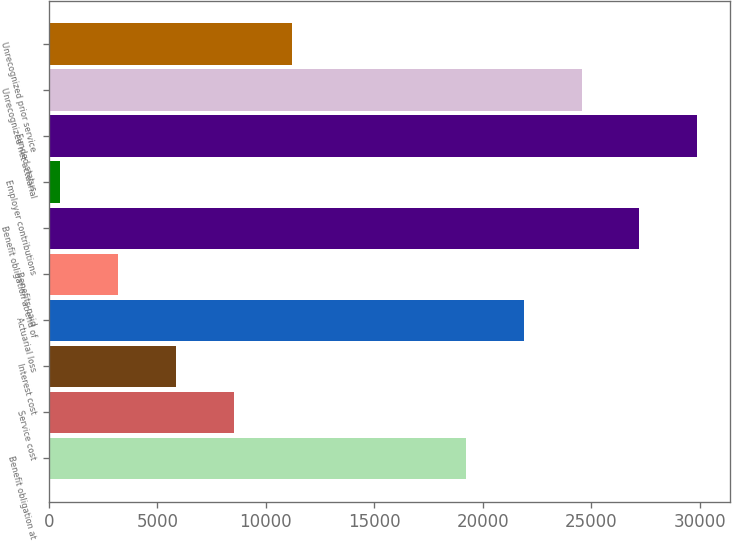Convert chart. <chart><loc_0><loc_0><loc_500><loc_500><bar_chart><fcel>Benefit obligation at<fcel>Service cost<fcel>Interest cost<fcel>Actuarial loss<fcel>Benefits paid<fcel>Benefit obligation at end of<fcel>Employer contributions<fcel>Funded status<fcel>Unrecognized net actuarial<fcel>Unrecognized prior service<nl><fcel>19209.4<fcel>8524.6<fcel>5853.4<fcel>21880.6<fcel>3182.2<fcel>27223<fcel>511<fcel>29894.2<fcel>24551.8<fcel>11195.8<nl></chart> 